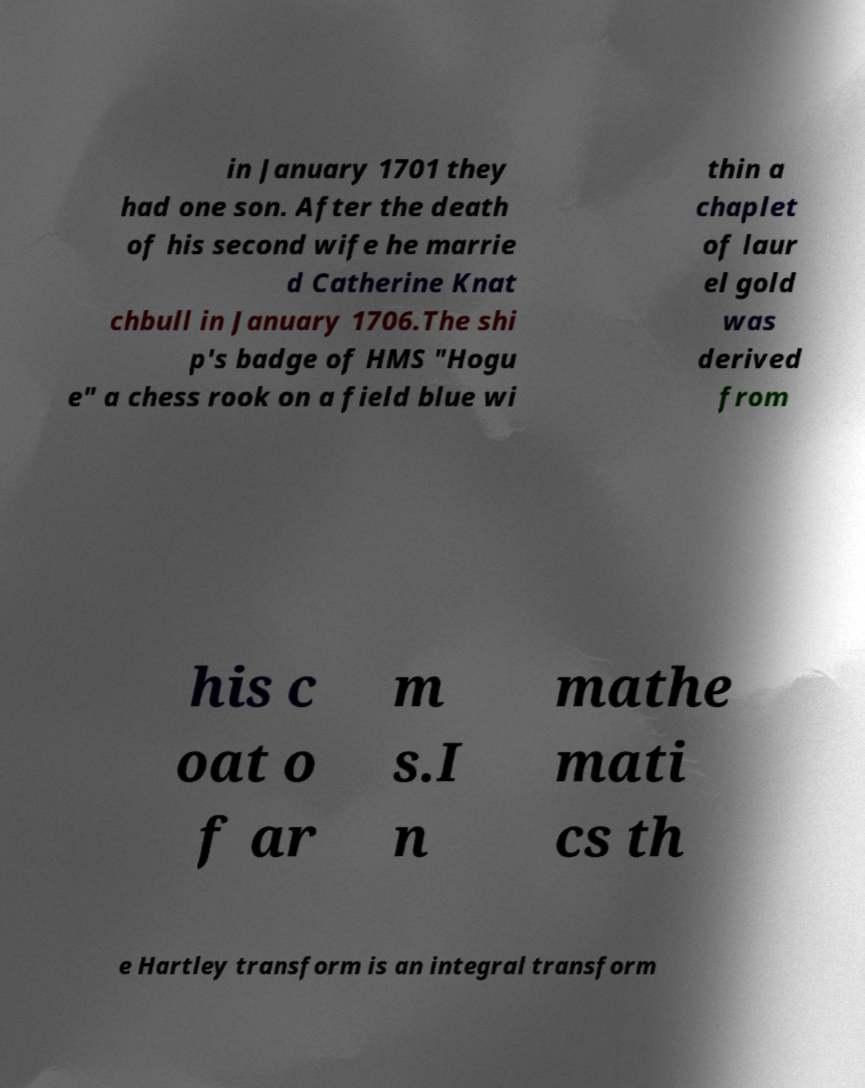Could you assist in decoding the text presented in this image and type it out clearly? in January 1701 they had one son. After the death of his second wife he marrie d Catherine Knat chbull in January 1706.The shi p's badge of HMS "Hogu e" a chess rook on a field blue wi thin a chaplet of laur el gold was derived from his c oat o f ar m s.I n mathe mati cs th e Hartley transform is an integral transform 